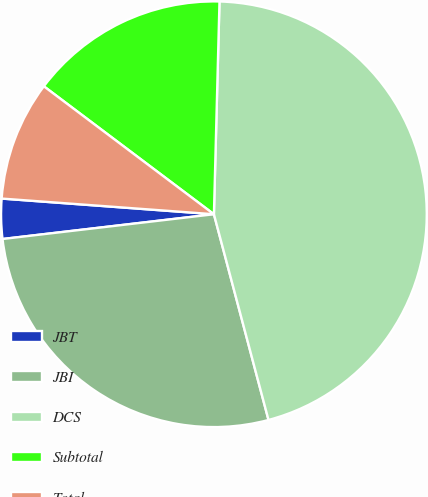Convert chart to OTSL. <chart><loc_0><loc_0><loc_500><loc_500><pie_chart><fcel>JBT<fcel>JBI<fcel>DCS<fcel>Subtotal<fcel>Total<nl><fcel>3.03%<fcel>27.27%<fcel>45.45%<fcel>15.15%<fcel>9.09%<nl></chart> 